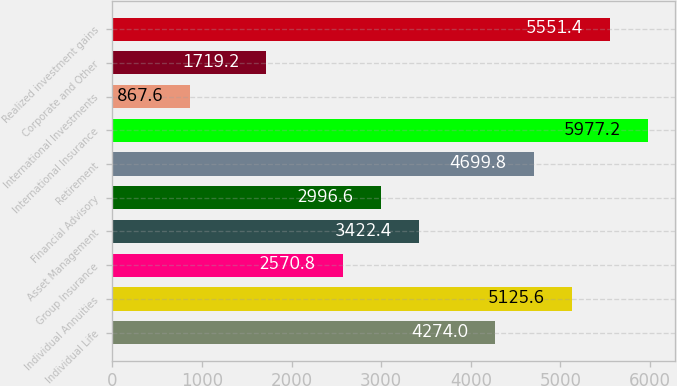<chart> <loc_0><loc_0><loc_500><loc_500><bar_chart><fcel>Individual Life<fcel>Individual Annuities<fcel>Group Insurance<fcel>Asset Management<fcel>Financial Advisory<fcel>Retirement<fcel>International Insurance<fcel>International Investments<fcel>Corporate and Other<fcel>Realized investment gains<nl><fcel>4274<fcel>5125.6<fcel>2570.8<fcel>3422.4<fcel>2996.6<fcel>4699.8<fcel>5977.2<fcel>867.6<fcel>1719.2<fcel>5551.4<nl></chart> 